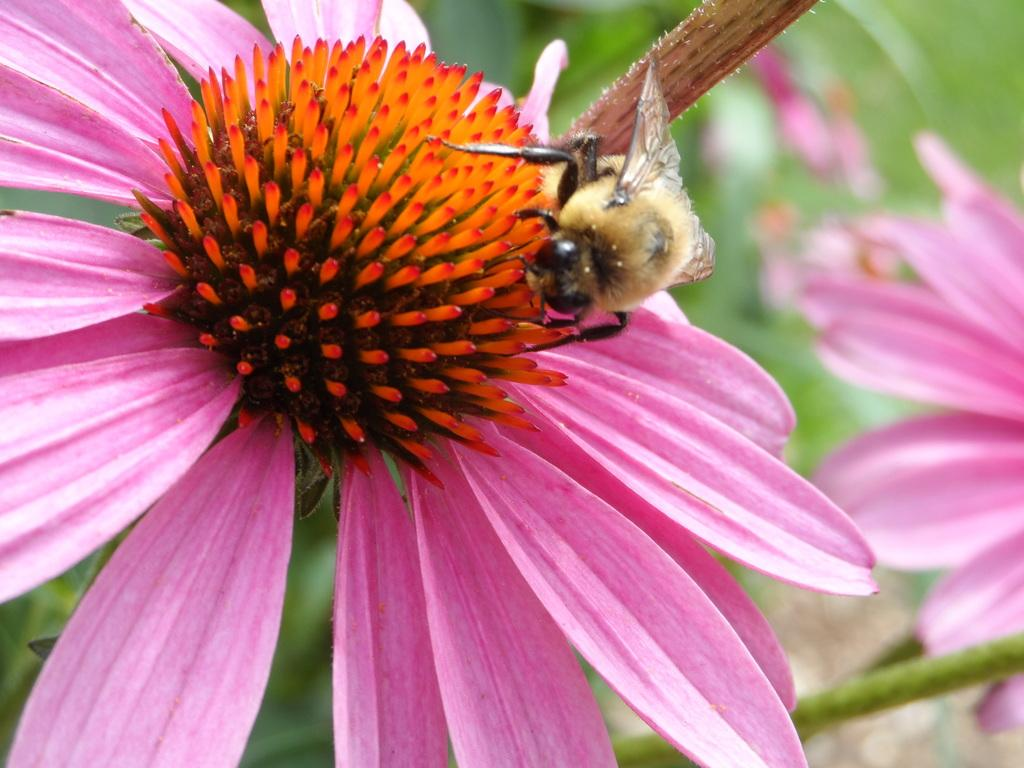What is the main subject of the image? There is a flower in the image. Can you describe the colors of the flower? The flower has pink and orange colors. Is there anything else present on the flower? Yes, there is an insect on the flower. Are there any other flowers visible in the image? Yes, there is another flower towards the right side of the image. What type of corn can be seen growing near the flower in the image? There is no corn present in the image; it features a flower with an insect and another flower nearby. 